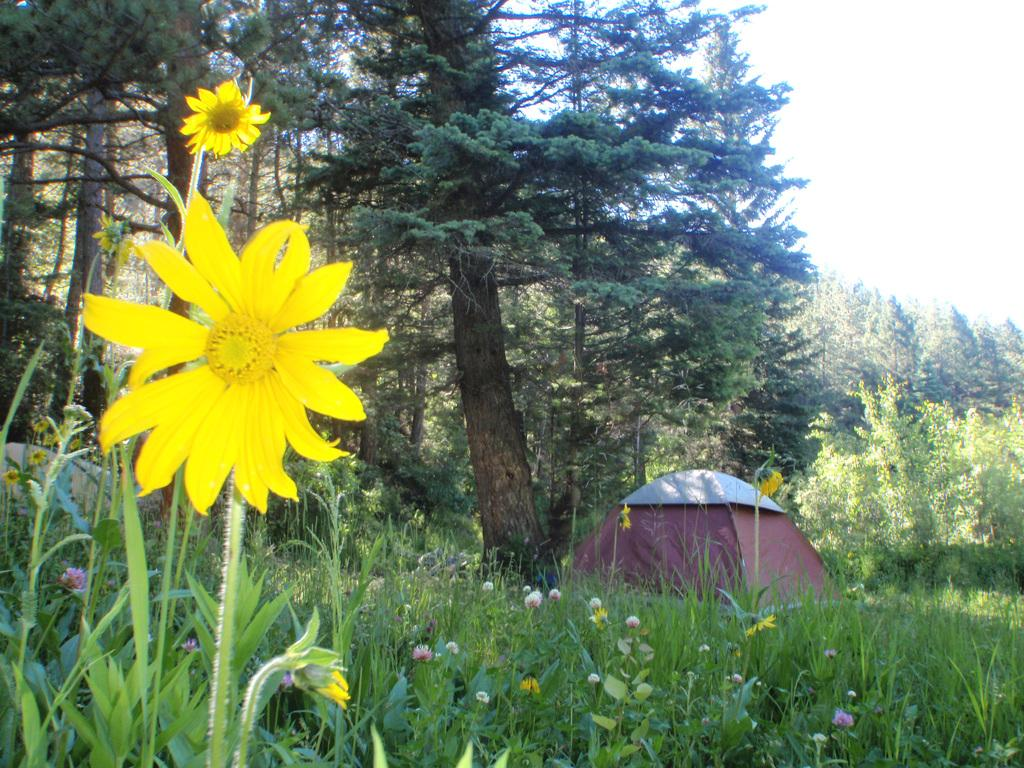What type of plants can be seen in the image? There are flower plants in the image. What color are the flowers? The flowers are yellow in color. What can be seen in the background of the image? There is a tent and trees in the background of the image. What is visible in the sky in the image? The sky is visible in the background of the image. What type of straw is used to create the canopy of the tent in the image? There is no straw mentioned in the image, nor is there any information about the tent's canopy material. 